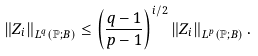<formula> <loc_0><loc_0><loc_500><loc_500>\left \| Z _ { i } \right \| _ { L ^ { q } \left ( \mathbb { P } ; B \right ) } \leq \left ( \frac { q - 1 } { p - 1 } \right ) ^ { i / 2 } \left \| Z _ { i } \right \| _ { L ^ { p } \left ( \mathbb { P } ; B \right ) } .</formula> 